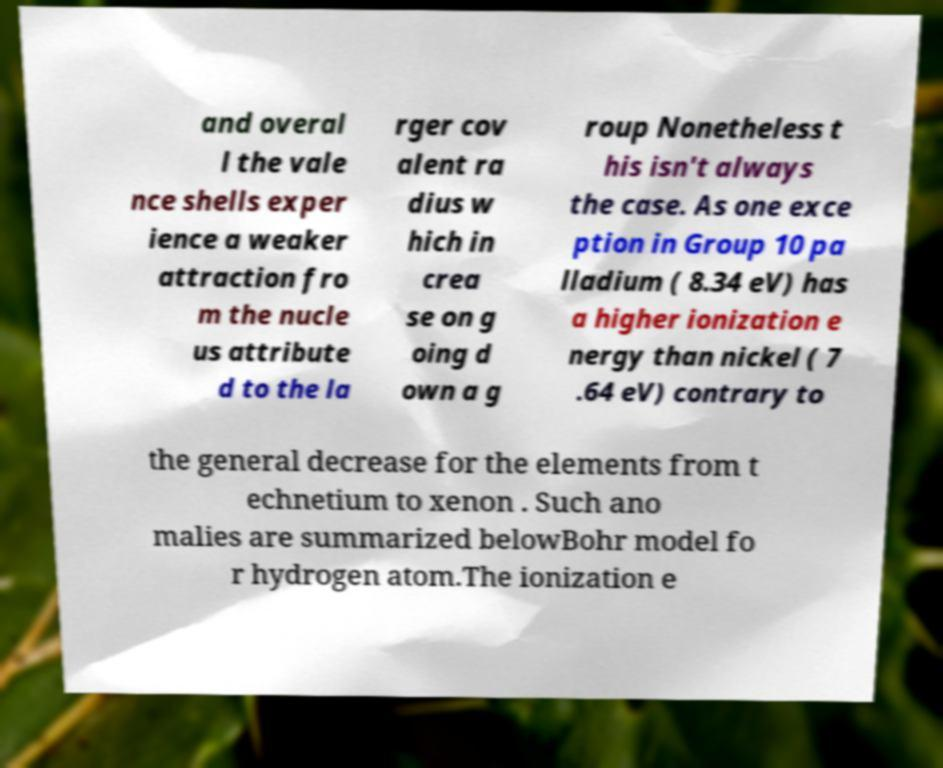I need the written content from this picture converted into text. Can you do that? and overal l the vale nce shells exper ience a weaker attraction fro m the nucle us attribute d to the la rger cov alent ra dius w hich in crea se on g oing d own a g roup Nonetheless t his isn't always the case. As one exce ption in Group 10 pa lladium ( 8.34 eV) has a higher ionization e nergy than nickel ( 7 .64 eV) contrary to the general decrease for the elements from t echnetium to xenon . Such ano malies are summarized belowBohr model fo r hydrogen atom.The ionization e 